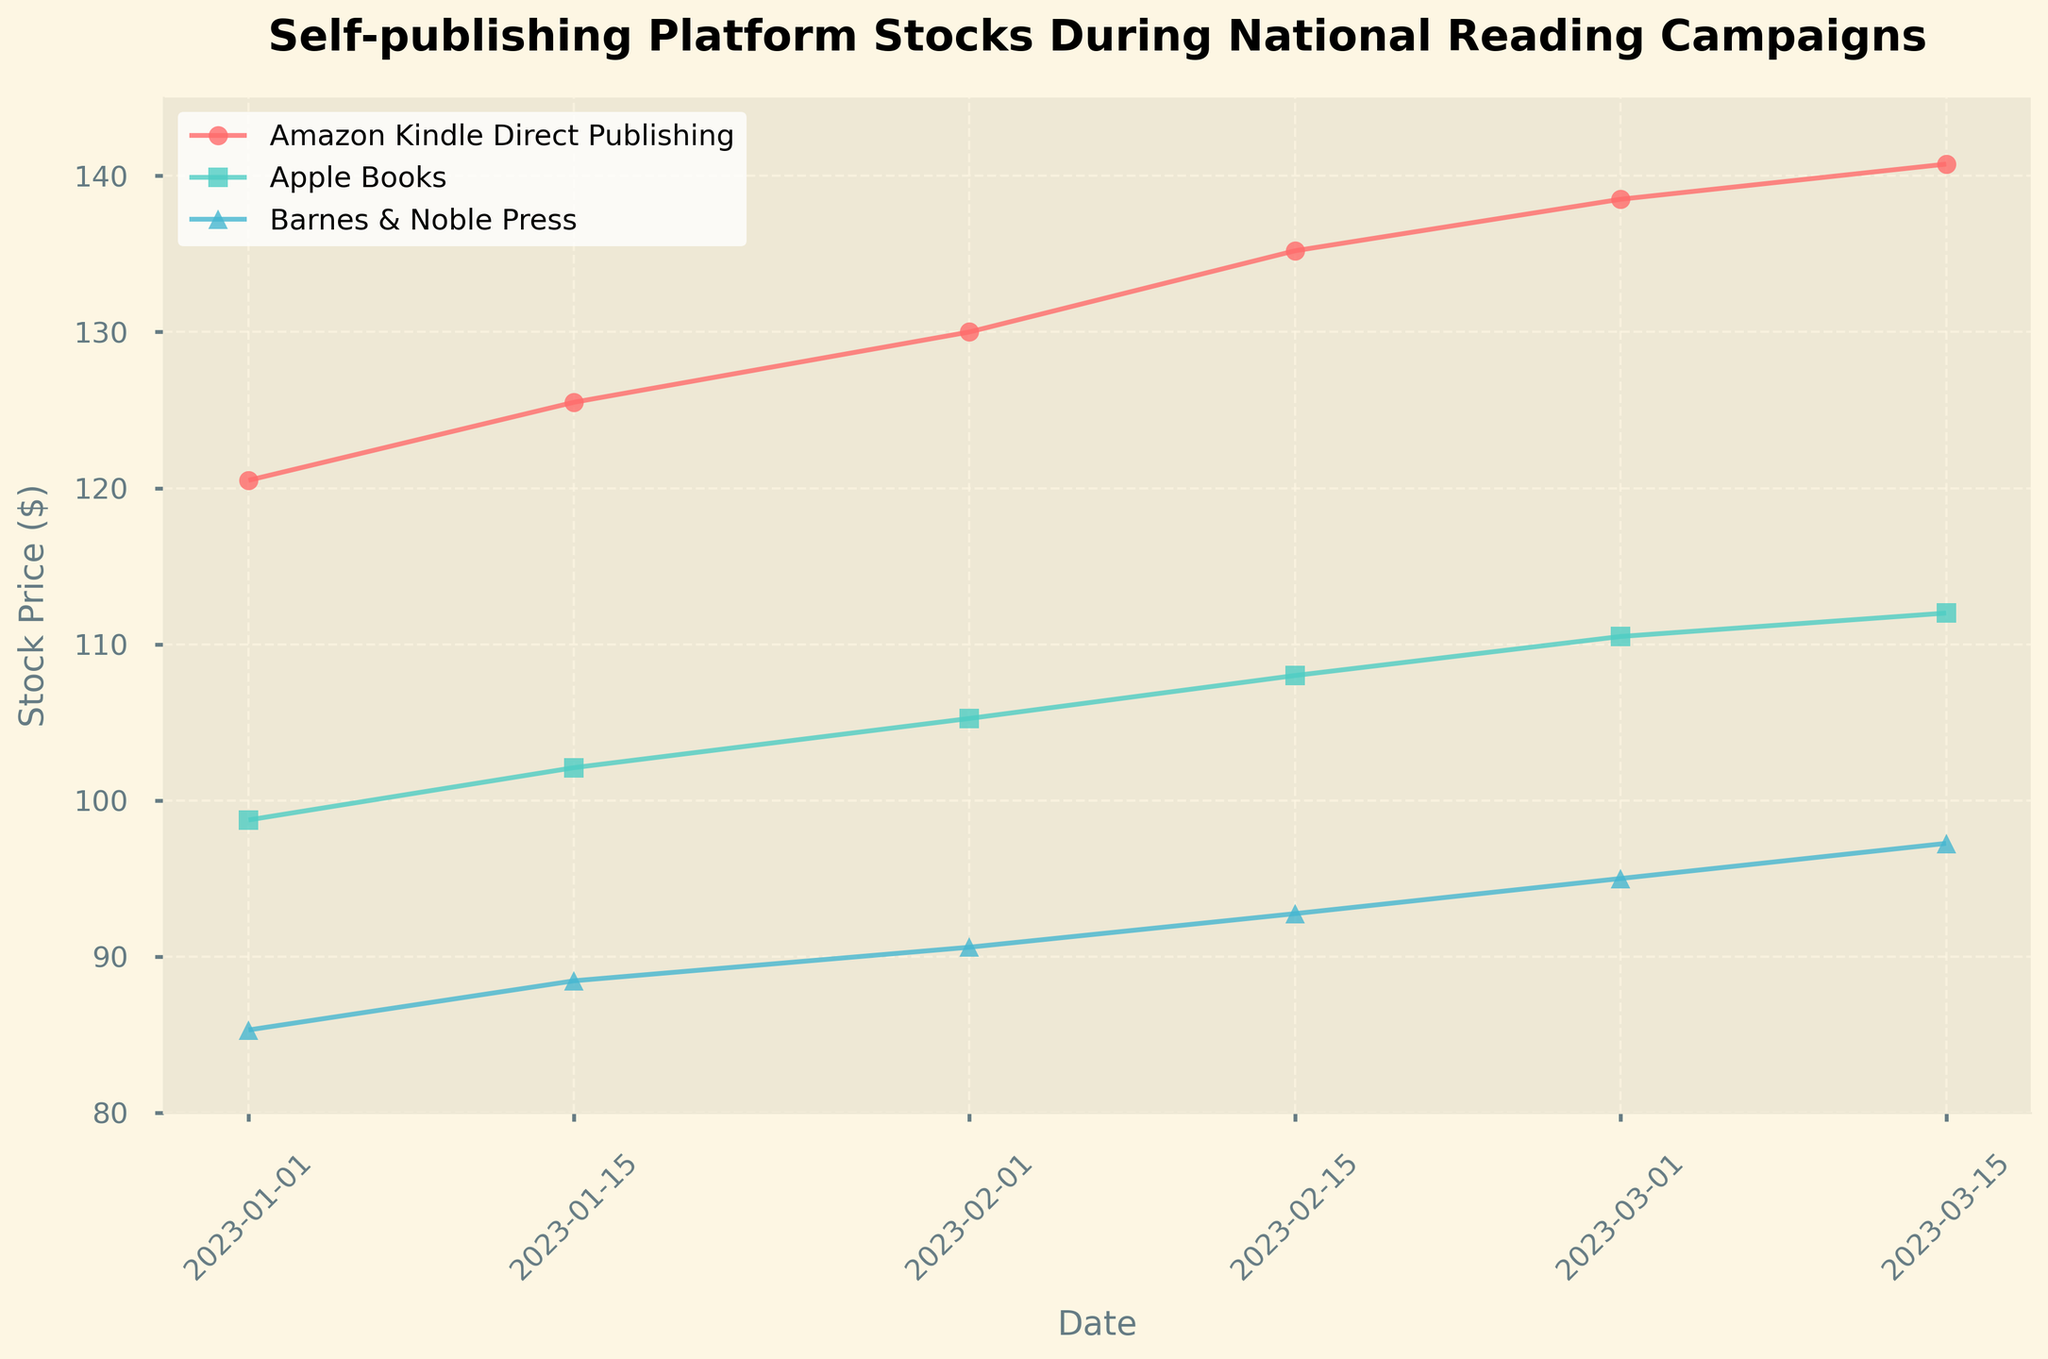What is the title of the figure? The title is located at the top of the plot, it is usually in a larger and bolder font compared to other text. It reads "Self-publishing Platform Stocks During National Reading Campaigns".
Answer: Self-publishing Platform Stocks During National Reading Campaigns Which company had the highest stock price on January 1, 2023? By examining the stock prices on January 1, 2023, for each company, we can see that Amazon Kindle Direct Publishing has the highest price, $120.50.
Answer: Amazon Kindle Direct Publishing How does the stock price of Apple Books change from February 1 to March 1, 2023? The stock price of Apple Books on February 1, 2023, is $105.25, and on March 1, 2023, it is $110.50. We calculate the difference as $110.50 - $105.25, which equals $5.25.
Answer: It increased by $5.25 What is the trend of Barnes & Noble Press' stock price between January 1 and March 15, 2023? By following the stock prices plotted for Barnes & Noble Press from January 1 ($85.30), January 15 ($88.45), February 1 ($90.60), February 15 ($92.75), March 1 ($95.00), and March 15 ($97.25), we observe a consistent upward trend.
Answer: It is increasing Comparing Apple Books and Amazon Kindle Direct Publishing, which company had a higher stock price on February 15, 2023, and by how much? On February 15, 2023, the stock price for Apple Books was $108.00, whereas for Amazon Kindle Direct Publishing it was $135.20. Calculating the difference, $135.20 - $108.00 equals $27.20.
Answer: Amazon Kindle Direct Publishing by $27.20 What is the range of stock prices for Amazon Kindle Direct Publishing in the dataset? The range is found by calculating the difference between the highest and lowest stock prices for Amazon Kindle Direct Publishing. The prices range from $120.50 (January 1) to $140.75 (March 15). The range is $140.75 - $120.50 = $20.25.
Answer: $20.25 On which date did Barnes & Noble Press experience the highest stock price, and what was the price? The highest stock price for Barnes & Noble Press can be visually identified by locating the highest point on its curve. This occurs on March 15, 2023, with a stock price of $97.25.
Answer: March 15, 2023, $97.25 How many data points are there in total for each company? Each company's stock price is recorded on 6 different dates. By counting the total points on each company's graph or curve, we confirm there are 6 data points per company.
Answer: 6 Which company’s stock showed the most growth from January 1, 2023, to March 15, 2023? Calculating the growth over the specified period, we have:
- Amazon Kindle Direct Publishing: $140.75 - $120.50 = $20.25
- Apple Books: $112.00 - $98.75 = $13.25
- Barnes & Noble Press: $97.25 - $85.30 = $11.95
Amazon Kindle Direct Publishing shows the highest growth.
Answer: Amazon Kindle Direct Publishing What is the average stock price for Apple Books across all recorded dates? Summing up the stock prices for Apple Books ($98.75, $102.10, $105.25, $108.00, $110.50, and $112.00) gives a total of $636.60. Dividing by the number of data points (6) yields an average stock price of $636.60 / 6 = $106.10.
Answer: $106.10 